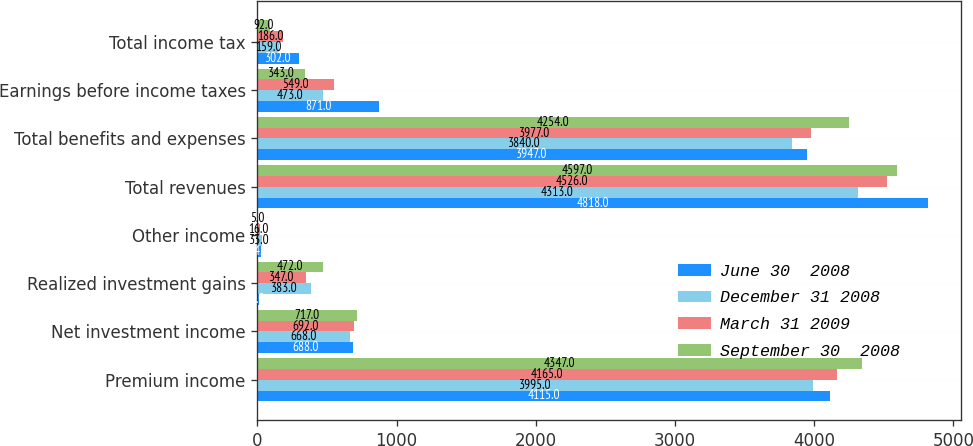Convert chart to OTSL. <chart><loc_0><loc_0><loc_500><loc_500><stacked_bar_chart><ecel><fcel>Premium income<fcel>Net investment income<fcel>Realized investment gains<fcel>Other income<fcel>Total revenues<fcel>Total benefits and expenses<fcel>Earnings before income taxes<fcel>Total income tax<nl><fcel>June 30  2008<fcel>4115<fcel>688<fcel>9<fcel>24<fcel>4818<fcel>3947<fcel>871<fcel>302<nl><fcel>December 31 2008<fcel>3995<fcel>668<fcel>383<fcel>33<fcel>4313<fcel>3840<fcel>473<fcel>159<nl><fcel>March 31 2009<fcel>4165<fcel>692<fcel>347<fcel>16<fcel>4526<fcel>3977<fcel>549<fcel>186<nl><fcel>September 30  2008<fcel>4347<fcel>717<fcel>472<fcel>5<fcel>4597<fcel>4254<fcel>343<fcel>92<nl></chart> 